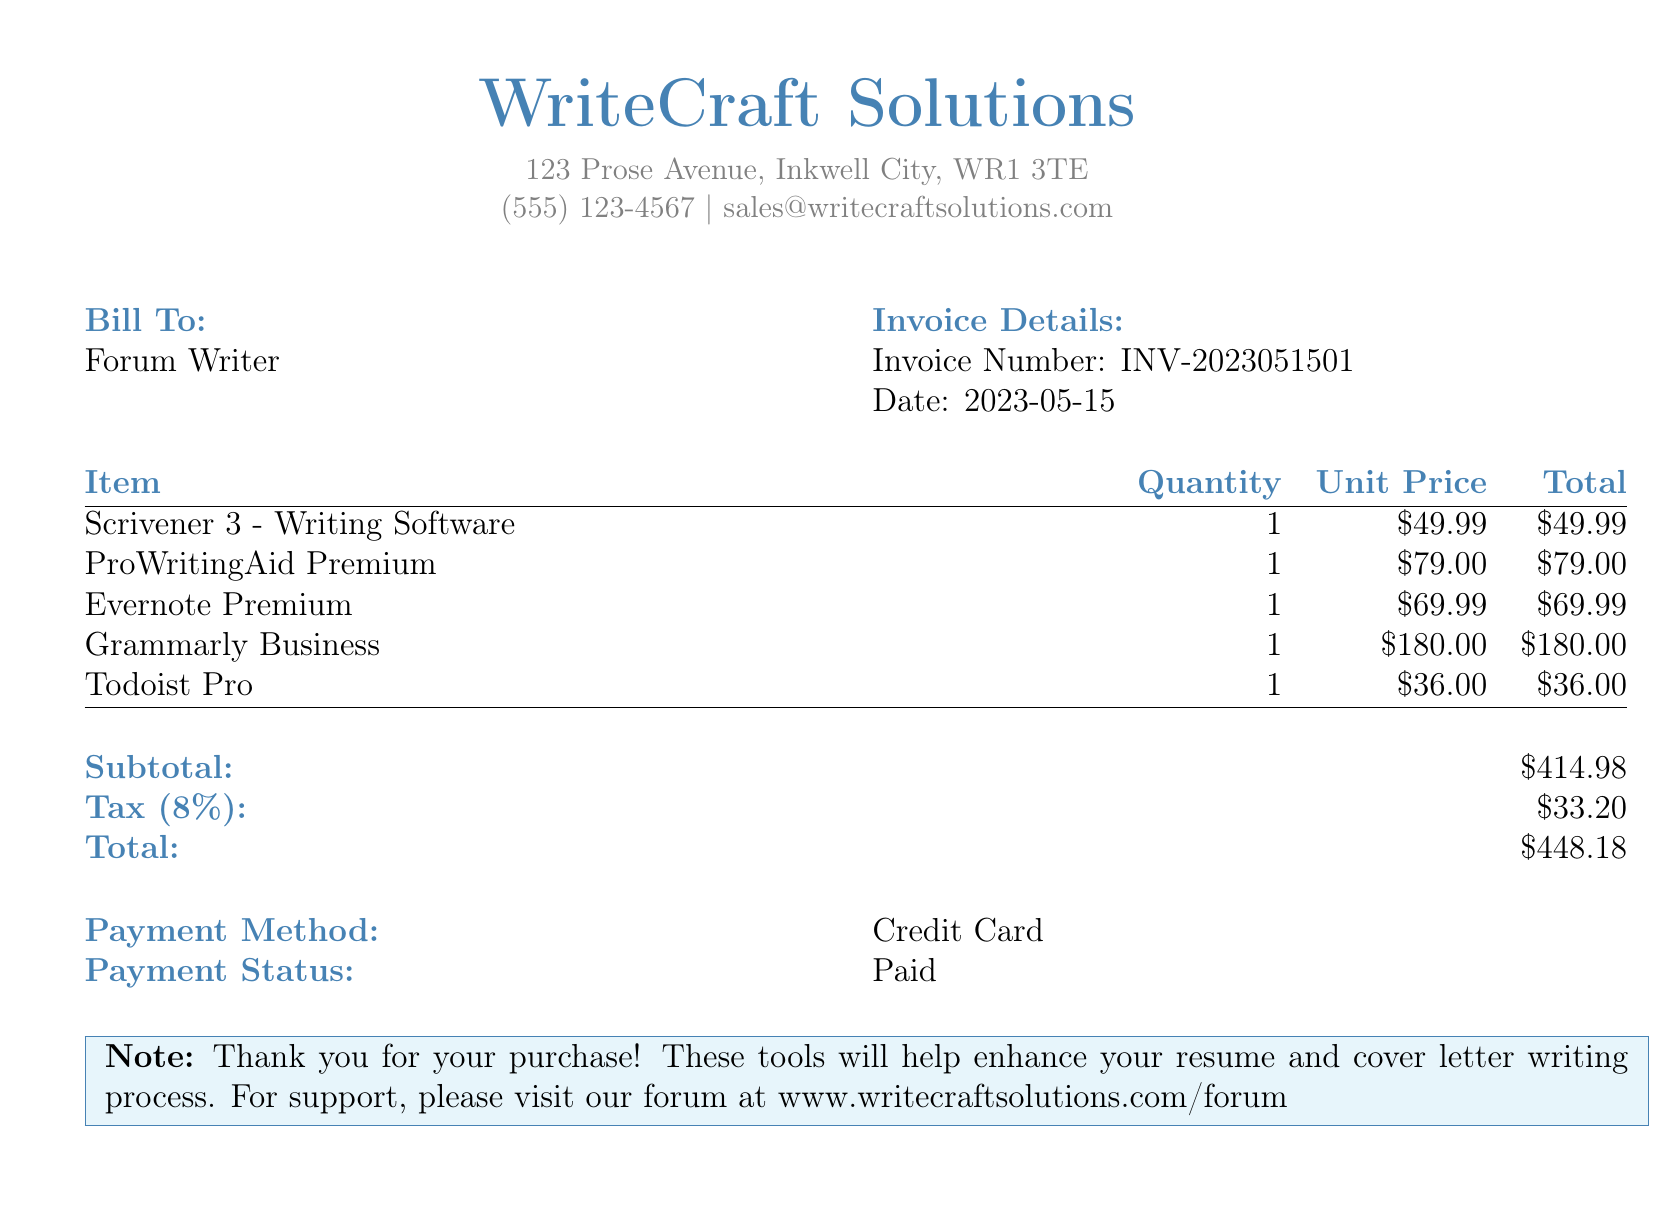What is the name of the writing software? The document lists Scrivener 3 as the writing software.
Answer: Scrivener 3 What is the total amount after tax? The total amount is given in the breakdown, which includes tax.
Answer: $448.18 What is the invoice number? The invoice number is specified in the document's details section.
Answer: INV-2023051501 How much is the unit price of ProWritingAid Premium? The unit price for ProWritingAid Premium is listed in the itemized section.
Answer: $79.00 What payment method was used? The payment method is recorded in the payment details section of the document.
Answer: Credit Card What is the subtotal of the bill? The subtotal is calculated before tax and presented in the document.
Answer: $414.98 What was the date of the invoice? The date of the invoice is provided in the invoice details section.
Answer: 2023-05-15 How many productivity tools are listed? The number of productivity tools is counted from the itemized section of the document.
Answer: 5 What is the tax rate applied to the subtotal? The tax rate is indicated next to the tax amount in the document.
Answer: 8% 